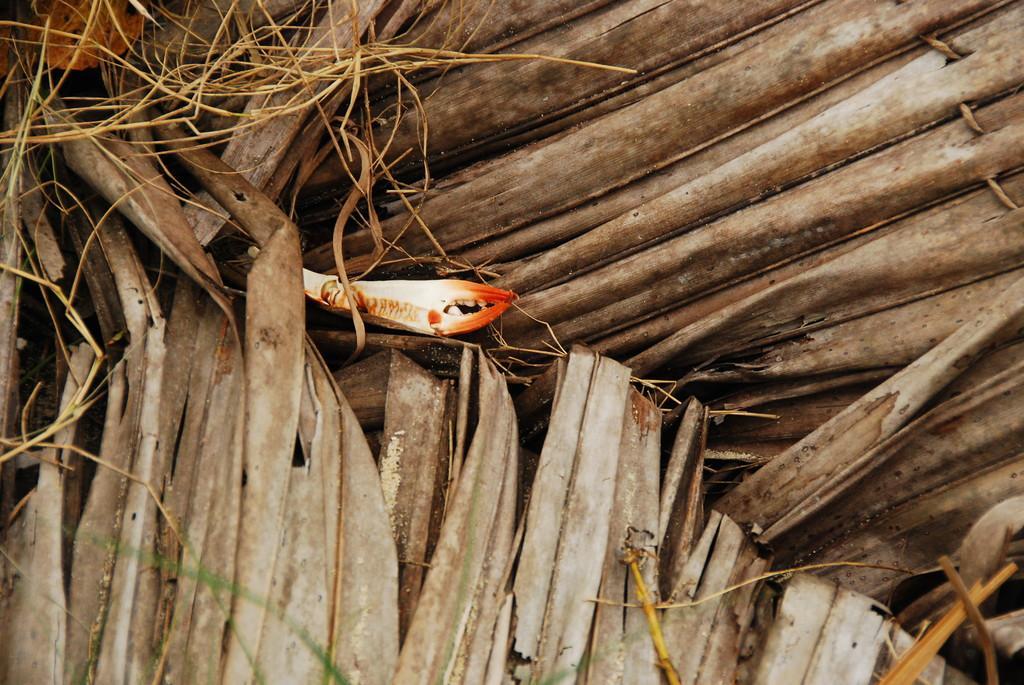Describe this image in one or two sentences. In this image we can see roof is made of dry leaves. In the middle of the image one orange and white color thing is present. 